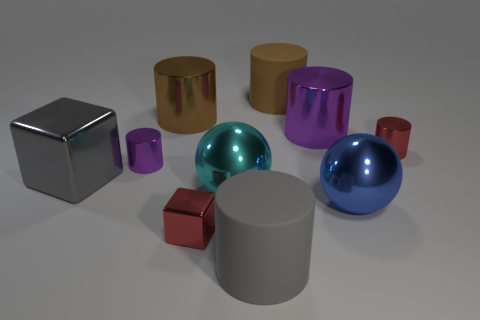Is the red object that is on the right side of the large cyan metal ball made of the same material as the brown cylinder right of the cyan sphere?
Your response must be concise. No. The tiny block is what color?
Your answer should be compact. Red. How many other objects are the same material as the cyan thing?
Your answer should be compact. 7. What number of purple objects are shiny things or tiny metal blocks?
Ensure brevity in your answer.  2. There is a big matte object behind the gray shiny block; does it have the same shape as the red object right of the small cube?
Make the answer very short. Yes. There is a large shiny cube; does it have the same color as the big cylinder that is in front of the small purple cylinder?
Your response must be concise. Yes. There is a rubber object that is in front of the big metallic cube; does it have the same color as the large block?
Offer a very short reply. Yes. How many things are either gray metal objects or shiny cylinders on the right side of the cyan ball?
Your response must be concise. 3. There is a large object that is in front of the cyan object and on the left side of the brown matte cylinder; what is its material?
Your answer should be compact. Rubber. What is the large gray thing in front of the cyan shiny ball made of?
Offer a very short reply. Rubber. 